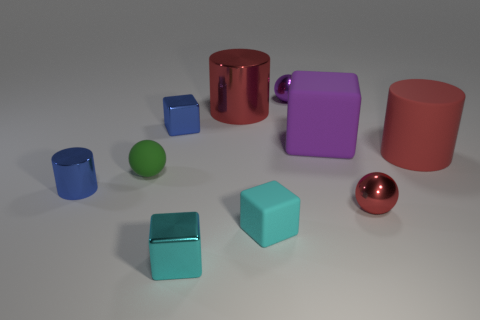Subtract all cubes. How many objects are left? 6 Add 3 cyan shiny cubes. How many cyan shiny cubes are left? 4 Add 7 cyan things. How many cyan things exist? 9 Subtract 0 gray cylinders. How many objects are left? 10 Subtract all green rubber balls. Subtract all small green rubber things. How many objects are left? 8 